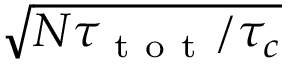<formula> <loc_0><loc_0><loc_500><loc_500>\sqrt { N \tau _ { t o t } / \tau _ { c } }</formula> 